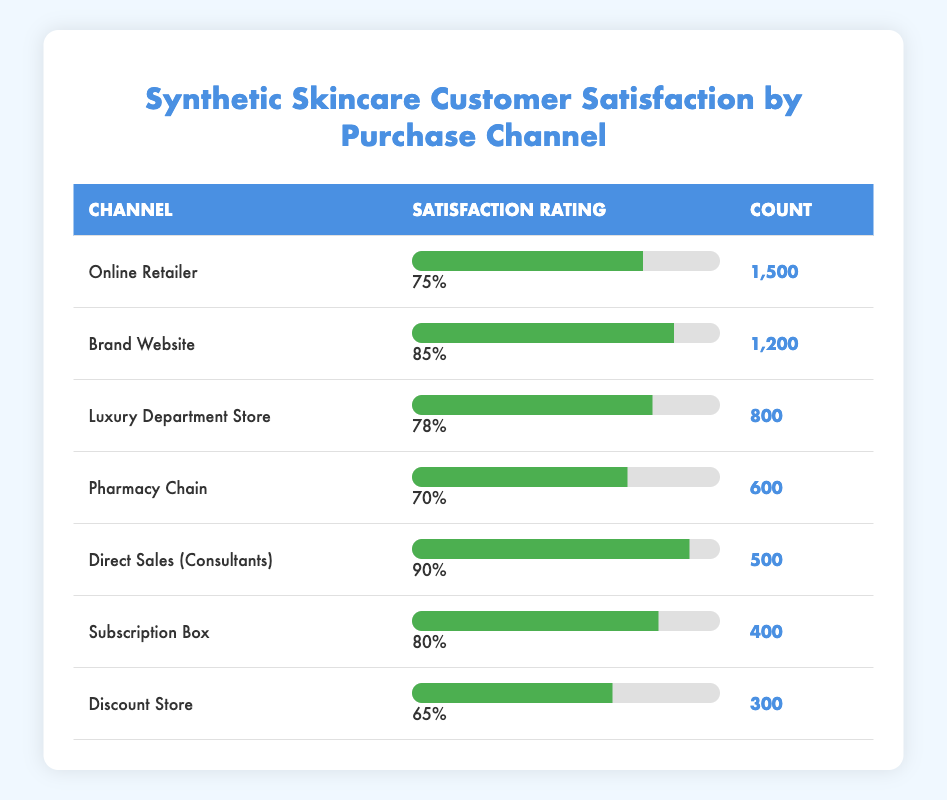What is the satisfaction rating from the Brand Website channel? The table indicates the satisfaction rating for the Brand Website is explicitly listed in the corresponding row. It shows a satisfaction rating of 85%.
Answer: 85% Which channel has the highest satisfaction rating? By comparing the satisfaction ratings across all channels, the highest rating is associated with Direct Sales (Consultants), which has a rating of 90%.
Answer: Direct Sales (Consultants) How many customers rated their satisfaction with products purchased through Luxury Department Stores? The count of customers who rated their satisfaction is given in the row for Luxury Department Store, indicating that 800 customers provided their ratings.
Answer: 800 What is the average satisfaction rating across all channels? To calculate the average satisfaction rating, sum the ratings from each channel (75 + 85 + 78 + 70 + 90 + 80 + 65 = 543) and divide by the number of channels (7). This gives an average satisfaction rating of 543/7, which is approximately 77.57.
Answer: Approximately 77.57 True or False: The satisfaction rating for Discount Store is higher than that of Online Retailer. The satisfaction rating for Discount Store is 65%, while the Online Retailer has a satisfaction rating of 75%. Since 65% is not higher than 75%, the statement is false.
Answer: False What is the difference in satisfaction ratings between the Brand Website and Pharmacy Chain? By examining the satisfaction ratings, the Brand Website has a rating of 85% and the Pharmacy Chain has a rating of 70%. The difference is calculated as 85 - 70 = 15%.
Answer: 15% What percentage of customers are satisfied with products bought from the Subscription Box channel? The Subscription Box channel has a satisfaction rating listed at 80%, indicating that this percentage of customers reported satisfaction with their purchases from this channel.
Answer: 80% Which channel has the least number of customer ratings? By reviewing the 'Count' column, it is apparent that the Discount Store has the lowest count at 300 customers who rated their satisfaction.
Answer: Discount Store What is the total count of customers who rated their satisfaction across all channels? To find the total count, sum the counts from each channel (1500 + 1200 + 800 + 600 + 500 + 400 + 300 = 5000). This indicates that a total of 5000 customers provided ratings.
Answer: 5000 